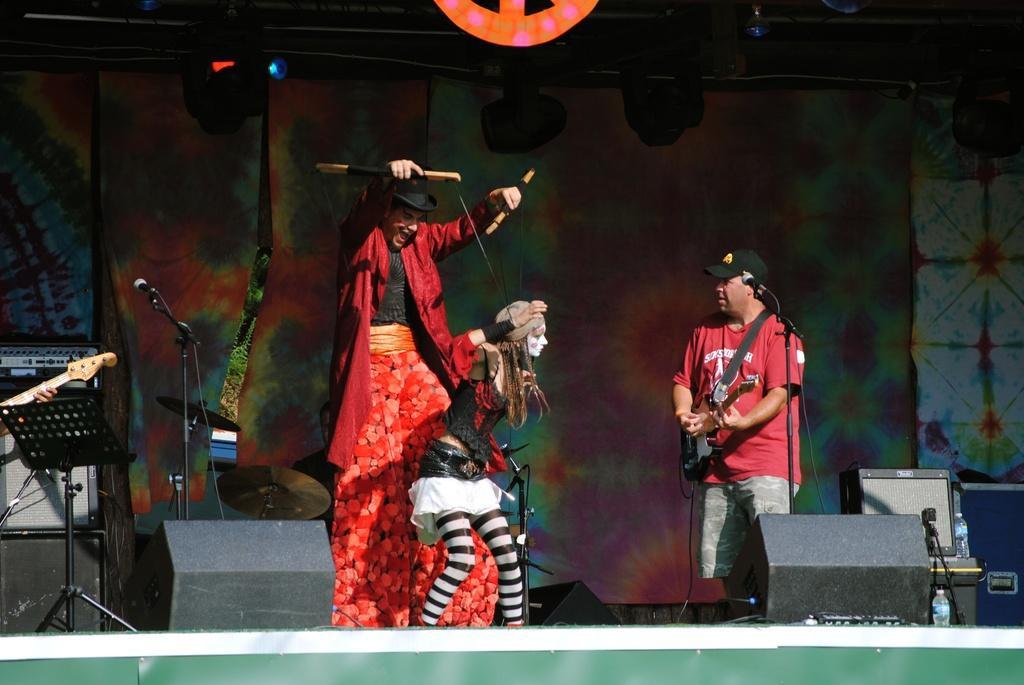In one or two sentences, can you explain what this image depicts? There is a person wearing hat is performing puppetry. In the back another person is playing guitar and wearing a cap. There are mics with mic stands. Also there is a book stand. In the back there are cymbals. Also there are curtains. Also there are speakers on the stage. At the top there are lights. 